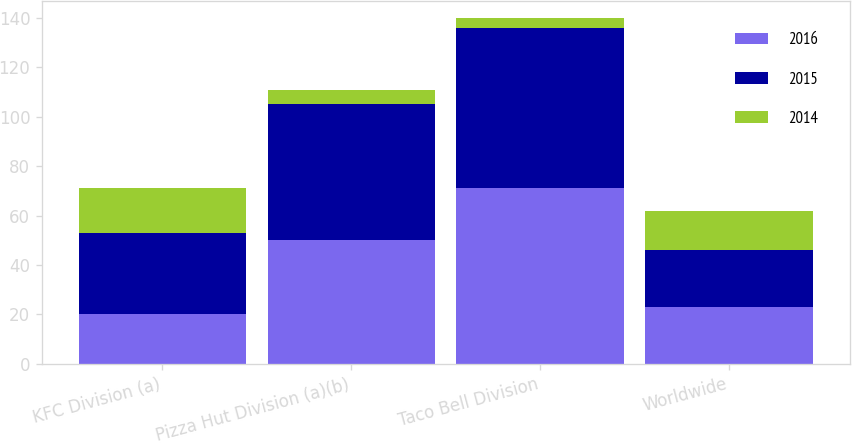<chart> <loc_0><loc_0><loc_500><loc_500><stacked_bar_chart><ecel><fcel>KFC Division (a)<fcel>Pizza Hut Division (a)(b)<fcel>Taco Bell Division<fcel>Worldwide<nl><fcel>2016<fcel>20<fcel>50<fcel>71<fcel>23<nl><fcel>2015<fcel>33<fcel>55<fcel>65<fcel>23<nl><fcel>2014<fcel>18<fcel>6<fcel>4<fcel>16<nl></chart> 